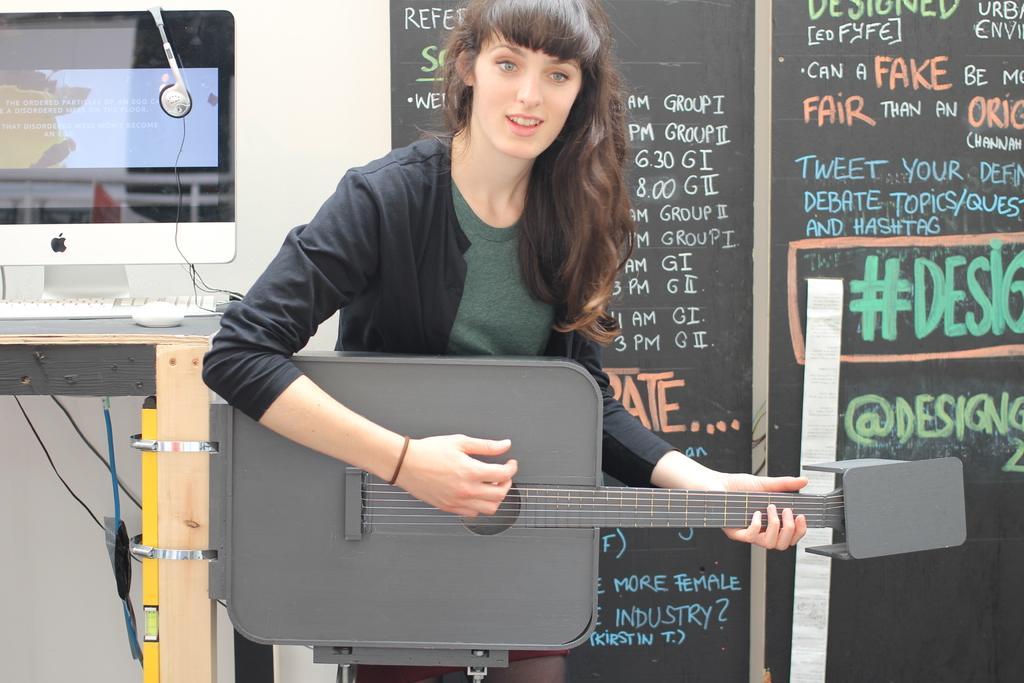Could you give a brief overview of what you see in this image? In this image we can see a computer on the table. There is a headphone placed on the monitor. A lady is playing a musical instrument. There is a blackboard on which some text written on it. There are few cables in the image. 